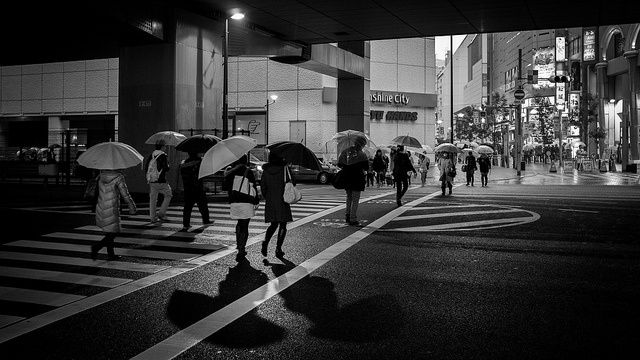Describe the objects in this image and their specific colors. I can see people in black, gray, darkgray, and lightgray tones, people in black and gray tones, people in black, gray, darkgray, and lightgray tones, people in black, gray, and lightgray tones, and people in black, gray, darkgray, and gainsboro tones in this image. 